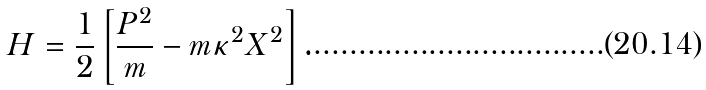Convert formula to latex. <formula><loc_0><loc_0><loc_500><loc_500>H = \frac { 1 } { 2 } \left [ \frac { P ^ { 2 } } { m } - m \kappa ^ { 2 } X ^ { 2 } \right ] .</formula> 